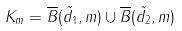Convert formula to latex. <formula><loc_0><loc_0><loc_500><loc_500>K _ { m } = \overline { B } ( \tilde { d _ { 1 } } , m ) \cup \overline { B } ( \tilde { d _ { 2 } } , m )</formula> 